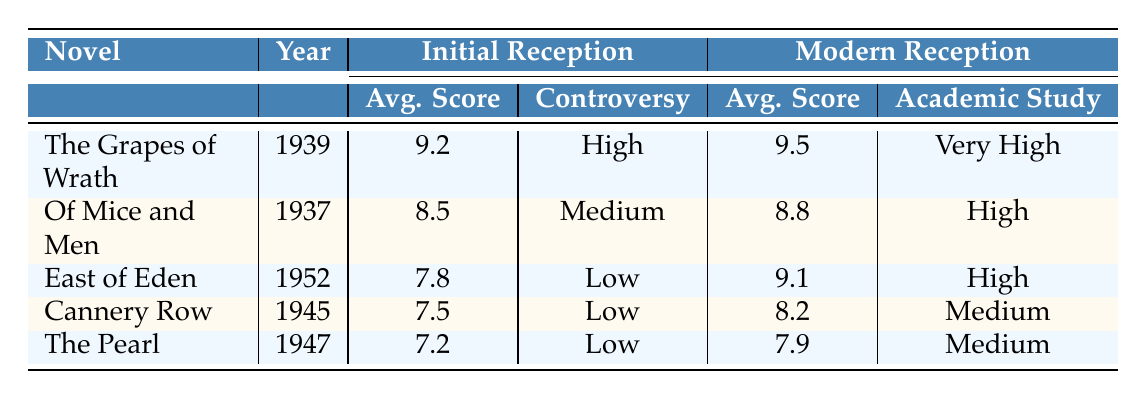What was the initial average critic score of "The Grapes of Wrath"? The table indicates that the initial average critic score for "The Grapes of Wrath" is 9.2, as listed in the "Initial Reception" section under "Avg. Score."
Answer: 9.2 Which novel published in 1945 had a low controversy level? The table shows that "Cannery Row," published in 1945, has a low controversy level under the "Initial Reception" section.
Answer: Cannery Row Did "East of Eden" win a Pulitzer Prize when it was initially released? According to the table, "East of Eden" does not have the Pulitzer Prize listed in its initial reception, indicating it did not win one.
Answer: No What is the difference between the modern average critic scores of "The Pearl" and "Of Mice and Men"? The modern average critic score for "The Pearl" is 7.9, and for "Of Mice and Men" it is 8.8. The difference is 8.8 - 7.9 = 0.9.
Answer: 0.9 Which novel shows the greatest improvement in average critic score from initial to modern reception? From the data, "East of Eden" has an initial score of 7.8 and a modern score of 9.1, giving it an improvement of 9.1 - 7.8 = 1.3. "The Grapes of Wrath" shows an improvement of 9.5 - 9.2 = 0.3. Comparing these, "East of Eden" shows the greatest improvement.
Answer: East of Eden Which novels were initially received with a controversy level labeled as "Low"? The table indicates that "East of Eden," "Cannery Row," and "The Pearl" all had a controversy level labeled as "Low" in their initial reception sections.
Answer: East of Eden, Cannery Row, The Pearl How many of Steinbeck's novels from the table were included in the Time Top 100 Novels list in their modern reception? In the modern reception, the novels "The Grapes of Wrath" and "East of Eden" are marked as being on the Time Top 100 Novels list. Thus, there are 2 novels.
Answer: 2 What is the academic study frequency of "The Grapes of Wrath"? The table states that the academic study frequency for "The Grapes of Wrath" is categorized as "Very High" under modern reception, as per the respective column.
Answer: Very High Did "Of Mice and Men" receive the National Book Award? The table shows that "Of Mice and Men" does not have the National Book Award listed under its initial reception, meaning it did not receive this accolade.
Answer: No 